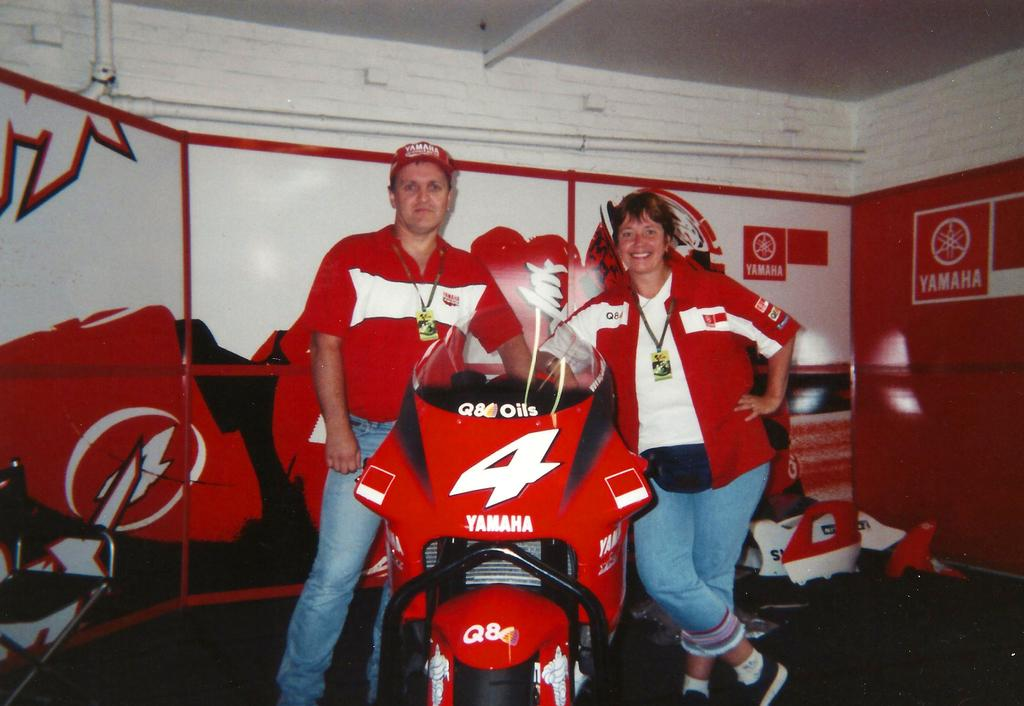<image>
Render a clear and concise summary of the photo. Motorcycle race bike in front of the white wall with Yamaha on it. 